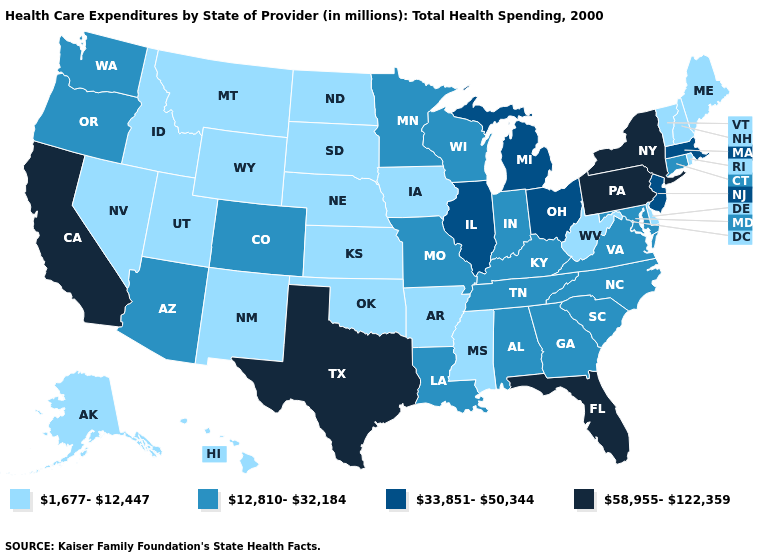Among the states that border Mississippi , which have the highest value?
Write a very short answer. Alabama, Louisiana, Tennessee. Does New Hampshire have the lowest value in the Northeast?
Keep it brief. Yes. What is the value of Iowa?
Short answer required. 1,677-12,447. Which states have the lowest value in the MidWest?
Short answer required. Iowa, Kansas, Nebraska, North Dakota, South Dakota. Among the states that border Massachusetts , does Rhode Island have the highest value?
Keep it brief. No. What is the value of Maryland?
Quick response, please. 12,810-32,184. What is the value of Oregon?
Concise answer only. 12,810-32,184. Among the states that border Maryland , which have the highest value?
Short answer required. Pennsylvania. How many symbols are there in the legend?
Short answer required. 4. Does Wisconsin have the lowest value in the MidWest?
Write a very short answer. No. Among the states that border Indiana , does Kentucky have the lowest value?
Keep it brief. Yes. Name the states that have a value in the range 12,810-32,184?
Keep it brief. Alabama, Arizona, Colorado, Connecticut, Georgia, Indiana, Kentucky, Louisiana, Maryland, Minnesota, Missouri, North Carolina, Oregon, South Carolina, Tennessee, Virginia, Washington, Wisconsin. How many symbols are there in the legend?
Answer briefly. 4. Name the states that have a value in the range 12,810-32,184?
Be succinct. Alabama, Arizona, Colorado, Connecticut, Georgia, Indiana, Kentucky, Louisiana, Maryland, Minnesota, Missouri, North Carolina, Oregon, South Carolina, Tennessee, Virginia, Washington, Wisconsin. Name the states that have a value in the range 58,955-122,359?
Answer briefly. California, Florida, New York, Pennsylvania, Texas. 